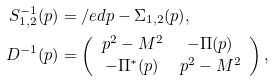Convert formula to latex. <formula><loc_0><loc_0><loc_500><loc_500>S _ { 1 , 2 } ^ { - 1 } ( p ) & = \slash e d p - \Sigma _ { 1 , 2 } ( p ) , \\ D ^ { - 1 } ( p ) & = \left ( \begin{array} { c c } p ^ { 2 } - M ^ { 2 } & - \Pi ( p ) \\ - \Pi ^ { * } ( p ) & p ^ { 2 } - M ^ { 2 } \end{array} \right ) ,</formula> 